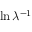Convert formula to latex. <formula><loc_0><loc_0><loc_500><loc_500>\ln \lambda ^ { - 1 }</formula> 